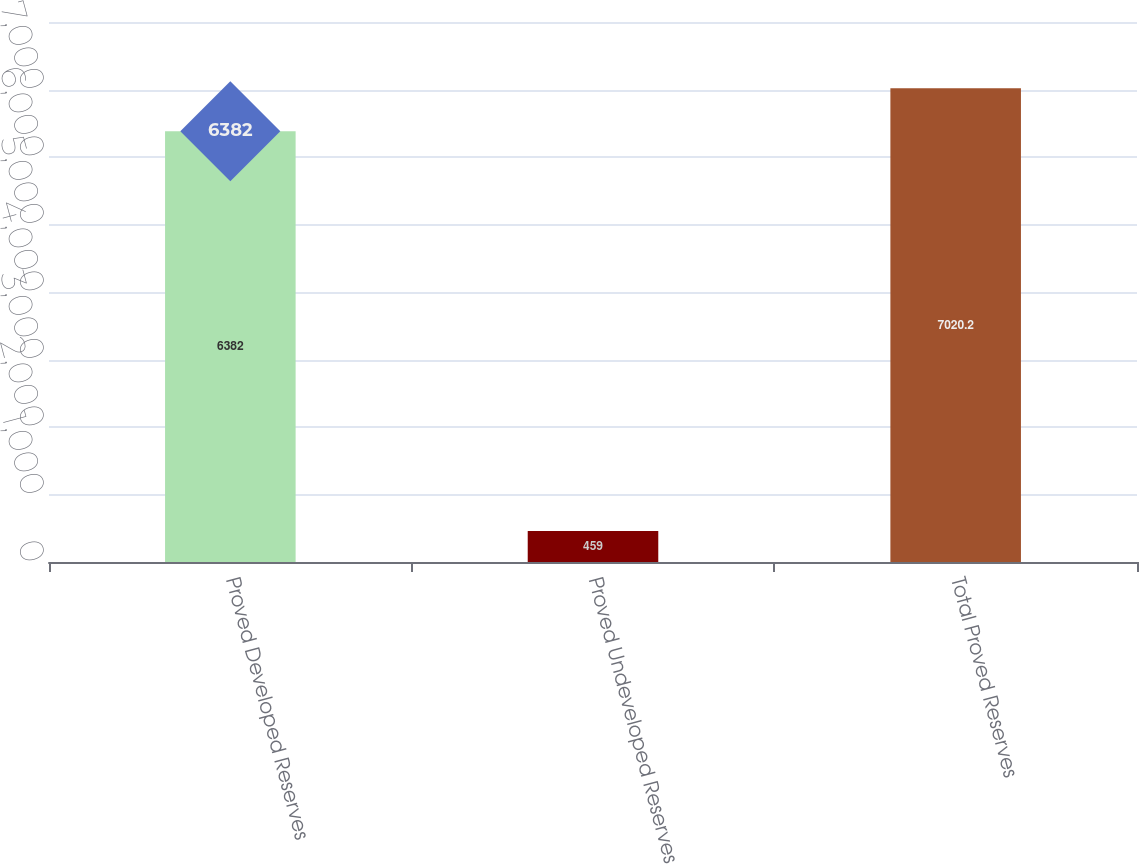Convert chart. <chart><loc_0><loc_0><loc_500><loc_500><bar_chart><fcel>Proved Developed Reserves<fcel>Proved Undeveloped Reserves<fcel>Total Proved Reserves<nl><fcel>6382<fcel>459<fcel>7020.2<nl></chart> 